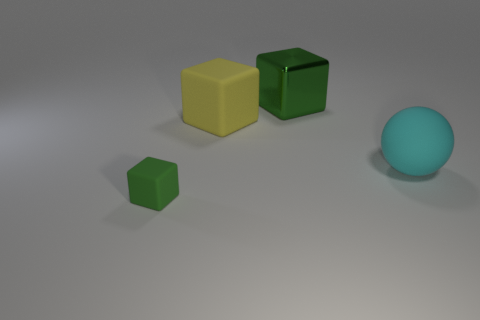Is there anything else that has the same material as the large green cube?
Your answer should be very brief. No. There is a ball that is made of the same material as the tiny green block; what is its size?
Provide a succinct answer. Large. Does the big metal thing have the same color as the thing that is in front of the cyan rubber ball?
Provide a succinct answer. Yes. There is a block that is behind the small green object and in front of the big green object; what is its material?
Offer a very short reply. Rubber. There is a shiny cube that is the same color as the small matte thing; what is its size?
Provide a short and direct response. Large. Does the thing that is in front of the big cyan ball have the same shape as the green object to the right of the tiny green rubber thing?
Ensure brevity in your answer.  Yes. Are any purple cubes visible?
Your answer should be very brief. No. What color is the other metal thing that is the same shape as the yellow thing?
Provide a short and direct response. Green. What is the color of the matte block that is the same size as the cyan rubber object?
Provide a succinct answer. Yellow. Do the tiny green object and the cyan object have the same material?
Give a very brief answer. Yes. 